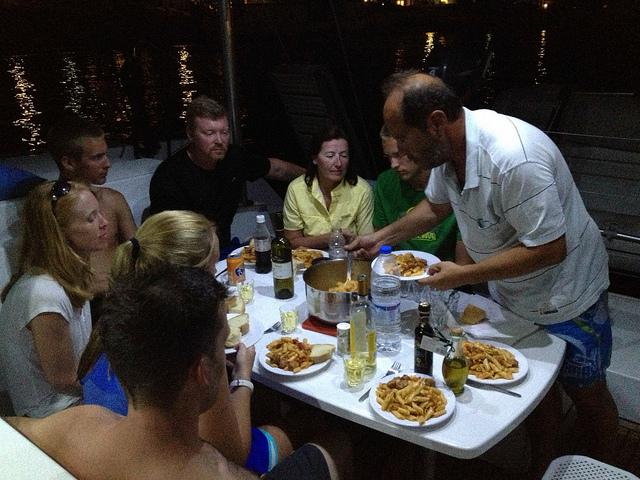Are the men happy?
Write a very short answer. No. Does this look boring?
Keep it brief. No. Is there anyone not smiling?
Give a very brief answer. Yes. What is on the plates?
Quick response, please. Fries. Are these people eating?
Short answer required. Yes. What color is the liquid?
Concise answer only. Clear. Do these people look like they are having a good day?
Keep it brief. Yes. What are the people eating?
Answer briefly. French fries. What are they cutting?
Write a very short answer. Pasta. What are the table and chairs made of?
Concise answer only. Plastic. Is this an old picture?
Answer briefly. No. How many bottles are pictured?
Short answer required. 5. What food is on the table?
Short answer required. Fries. What are these men eating?
Keep it brief. Pasta. Is anyone wearing a green shirt?
Be succinct. Yes. Are they humans?
Write a very short answer. Yes. What color is the table?
Concise answer only. White. How many women?
Concise answer only. 3. 